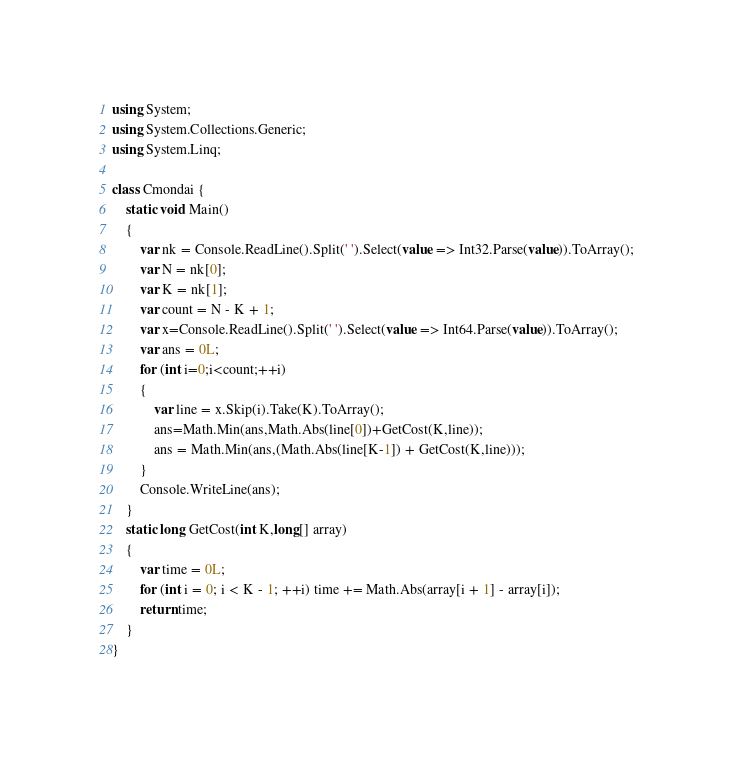Convert code to text. <code><loc_0><loc_0><loc_500><loc_500><_C#_>using System;
using System.Collections.Generic;
using System.Linq;

class Cmondai {
    static void Main()
    {
        var nk = Console.ReadLine().Split(' ').Select(value => Int32.Parse(value)).ToArray();
        var N = nk[0];
        var K = nk[1];
        var count = N - K + 1;
        var x=Console.ReadLine().Split(' ').Select(value => Int64.Parse(value)).ToArray();
        var ans = 0L;
        for (int i=0;i<count;++i)
        {
            var line = x.Skip(i).Take(K).ToArray();
            ans=Math.Min(ans,Math.Abs(line[0])+GetCost(K,line));
            ans = Math.Min(ans,(Math.Abs(line[K-1]) + GetCost(K,line)));
        }
        Console.WriteLine(ans);
    }
    static long GetCost(int K,long[] array)
    {
        var time = 0L;
        for (int i = 0; i < K - 1; ++i) time += Math.Abs(array[i + 1] - array[i]);
        return time;
    }
}
</code> 